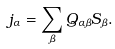Convert formula to latex. <formula><loc_0><loc_0><loc_500><loc_500>j _ { \alpha } = \sum _ { \beta } Q _ { \alpha \beta } S _ { \beta } .</formula> 